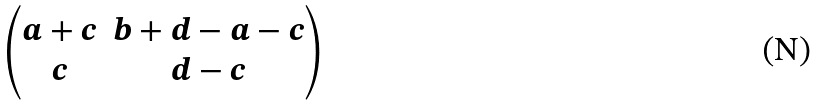<formula> <loc_0><loc_0><loc_500><loc_500>\begin{pmatrix} a + c & b + d - a - c \\ c & d - c \end{pmatrix}</formula> 